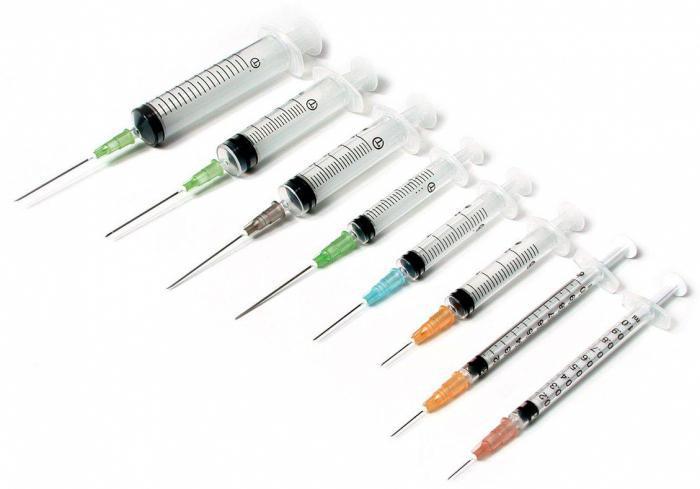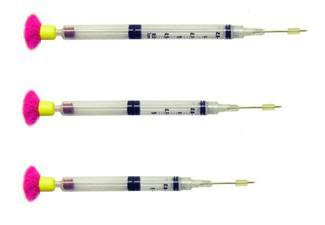The first image is the image on the left, the second image is the image on the right. Considering the images on both sides, is "There are exactly two syringes." valid? Answer yes or no. No. The first image is the image on the left, the second image is the image on the right. Evaluate the accuracy of this statement regarding the images: "There are no more than 2 syringes.". Is it true? Answer yes or no. No. 